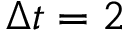Convert formula to latex. <formula><loc_0><loc_0><loc_500><loc_500>\Delta t = 2</formula> 